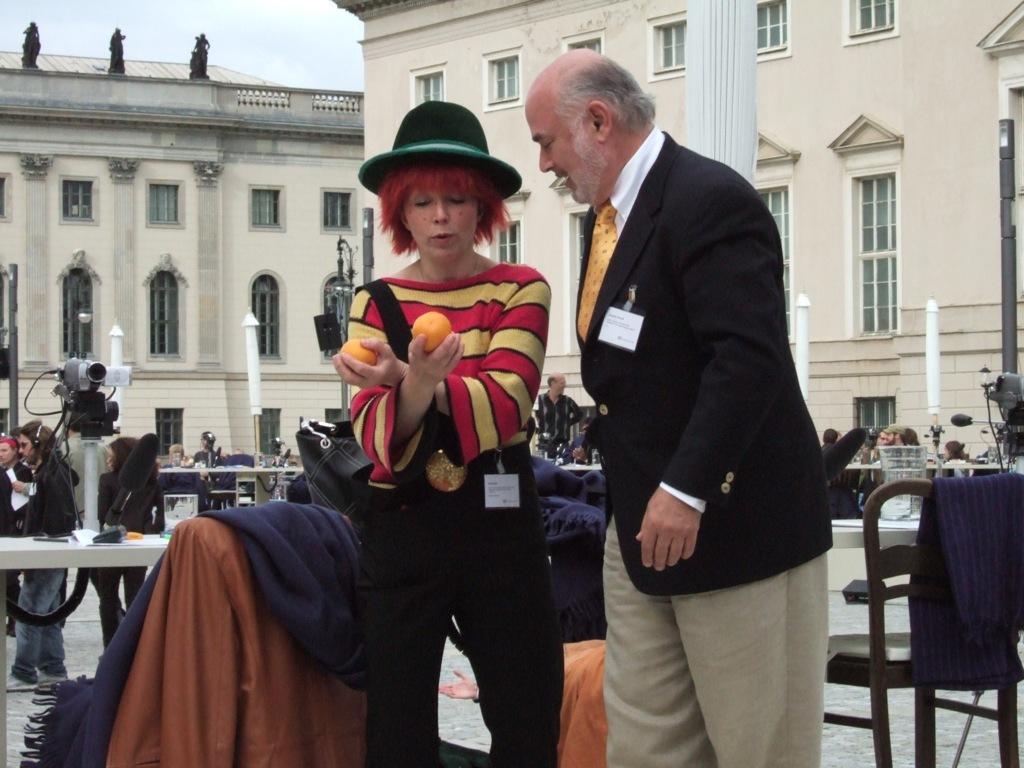Please provide a concise description of this image. At the top we can see sky. These are buildings on the background. We can see persons sitting and standing and few are walking. Here we can see one women wearing a black hat and holding oranges in her hands. We can see this man standing beside her and staring. Here we can see jackets on a chair. This is a camera. 